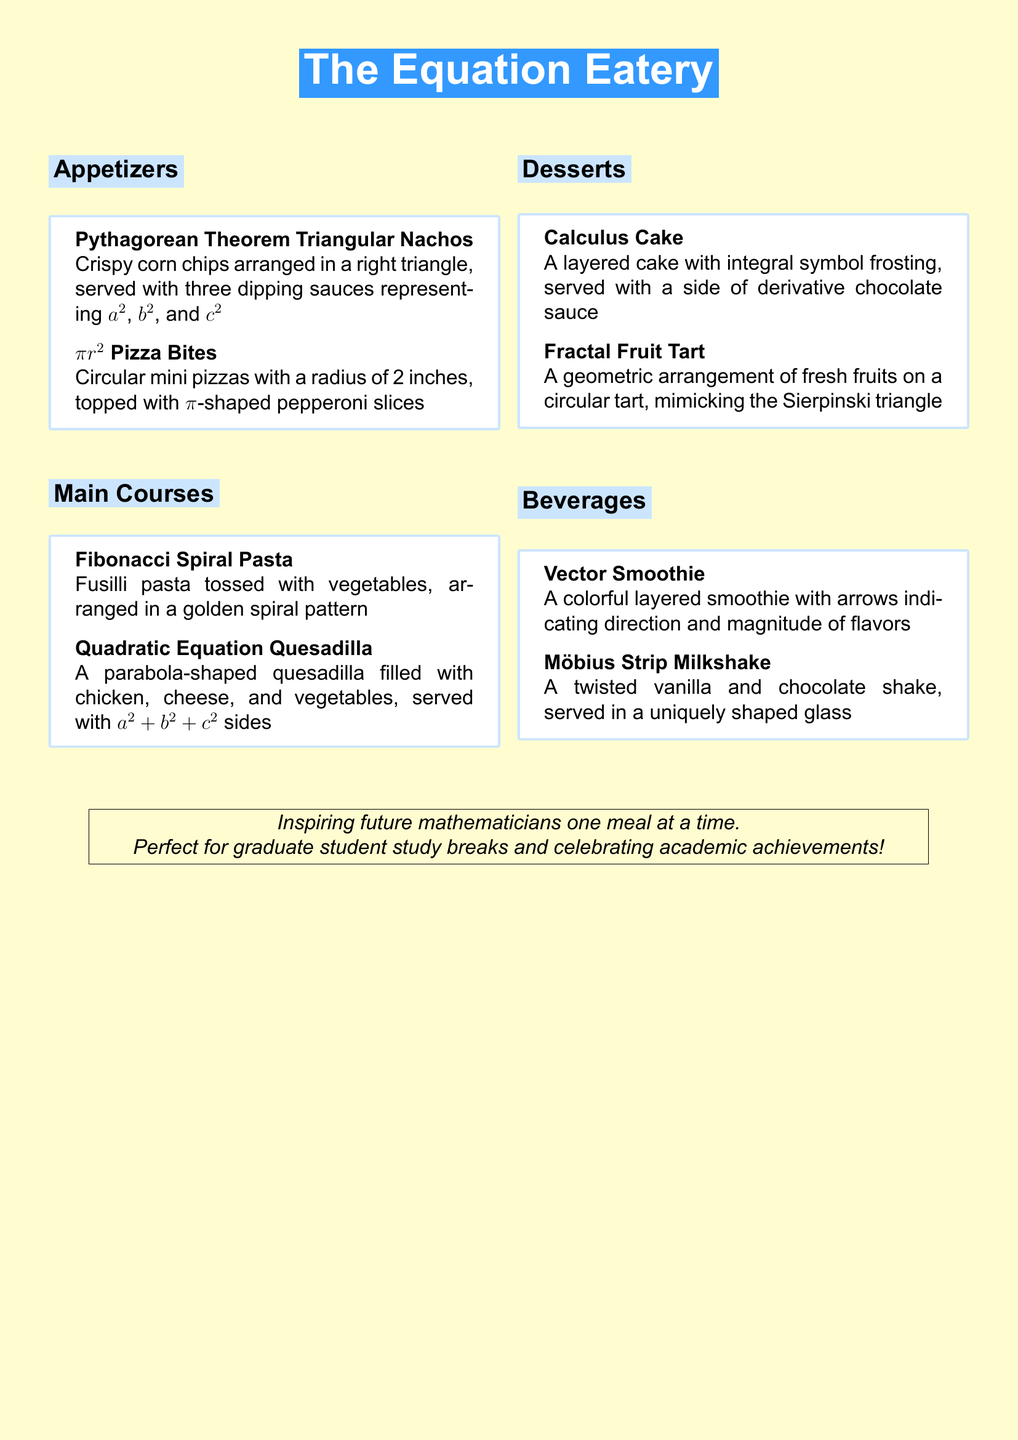What is the name of the appetizer that features corn chips? The appetizer featuring corn chips is called "Pythagorean Theorem Triangular Nachos."
Answer: Pythagorean Theorem Triangular Nachos How many dipping sauces are served with the nachos? The nachos are served with three dipping sauces, representing $a^2$, $b^2$, and $c^2$.
Answer: Three What shape is the pizza bite? The pizza bites are described as circular.
Answer: Circular Which dish is named after a mathematical sequence? The dish named after a mathematical sequence is "Fibonacci Spiral Pasta."
Answer: Fibonacci Spiral Pasta What type of sauce is served with the Calculus Cake? The sauce served with the Calculus Cake is described as derivative chocolate sauce.
Answer: Derivative chocolate sauce What geometric shape is featured in the Fractal Fruit Tart? The Fractal Fruit Tart mimics the Sierpinski triangle.
Answer: Sierpinski triangle What is the unique characteristic of the Möbius Strip Milkshake? The unique characteristic of the milkshake is that it is served in a uniquely shaped glass.
Answer: Uniquely shaped glass What do the layers in the Vector Smoothie represent? The layers in the smoothie represent direction and magnitude of flavors.
Answer: Direction and magnitude of flavors 